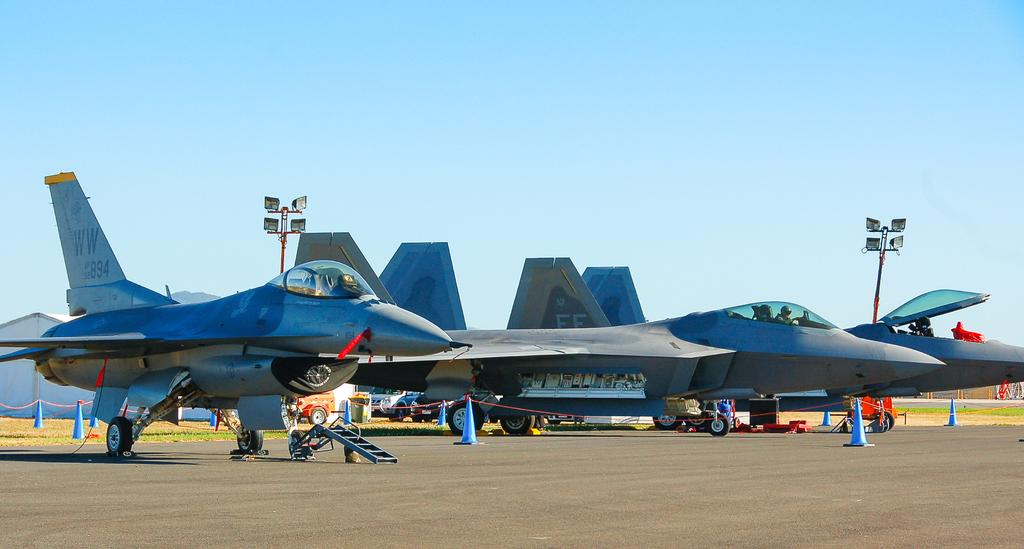What type of vehicles can be seen in the image? There are vehicles in the image. What structures are present in the image? There are houses in the image. What safety feature is present in the image? There are traffic cones in the image. What type of terrain is visible in the image? Grass is present in the image. What type of poles can be seen in the image? There are poles in the image. What type of lights are present in the image? There are lights in the image. What can be seen in the background of the image? The sky is visible in the background of the image. What part of the knee is visible in the image? There is no knee present in the image. What type of surprise can be seen in the image? There is no surprise present in the image. 